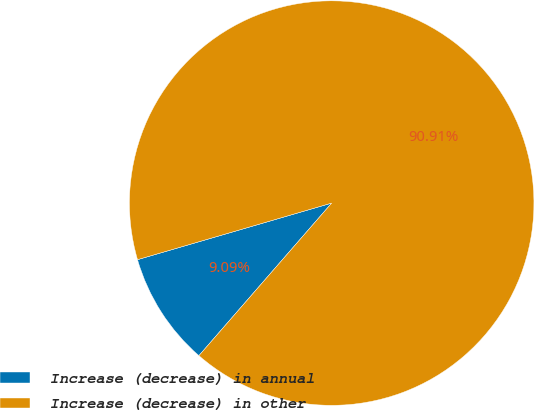<chart> <loc_0><loc_0><loc_500><loc_500><pie_chart><fcel>Increase (decrease) in annual<fcel>Increase (decrease) in other<nl><fcel>9.09%<fcel>90.91%<nl></chart> 